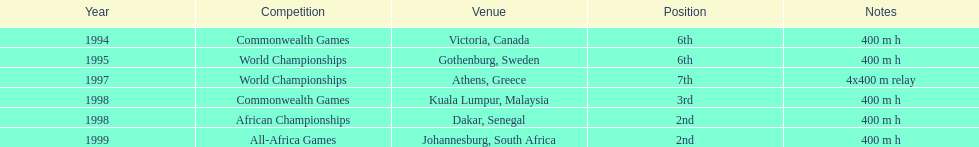What is the quantity of titles ken harden has won? 6. 